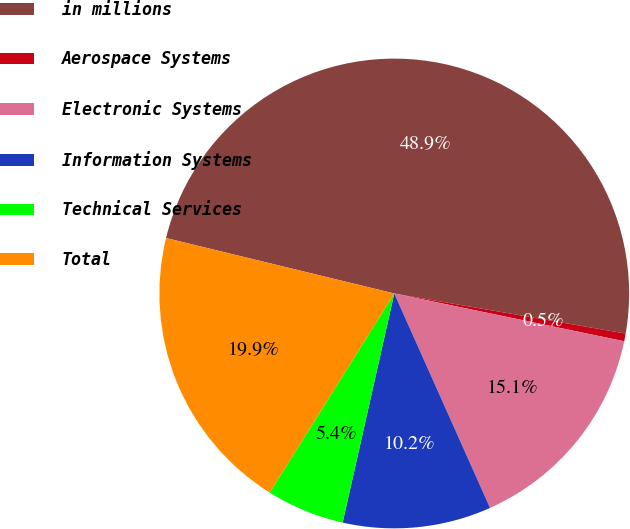Convert chart. <chart><loc_0><loc_0><loc_500><loc_500><pie_chart><fcel>in millions<fcel>Aerospace Systems<fcel>Electronic Systems<fcel>Information Systems<fcel>Technical Services<fcel>Total<nl><fcel>48.93%<fcel>0.53%<fcel>15.05%<fcel>10.21%<fcel>5.37%<fcel>19.89%<nl></chart> 